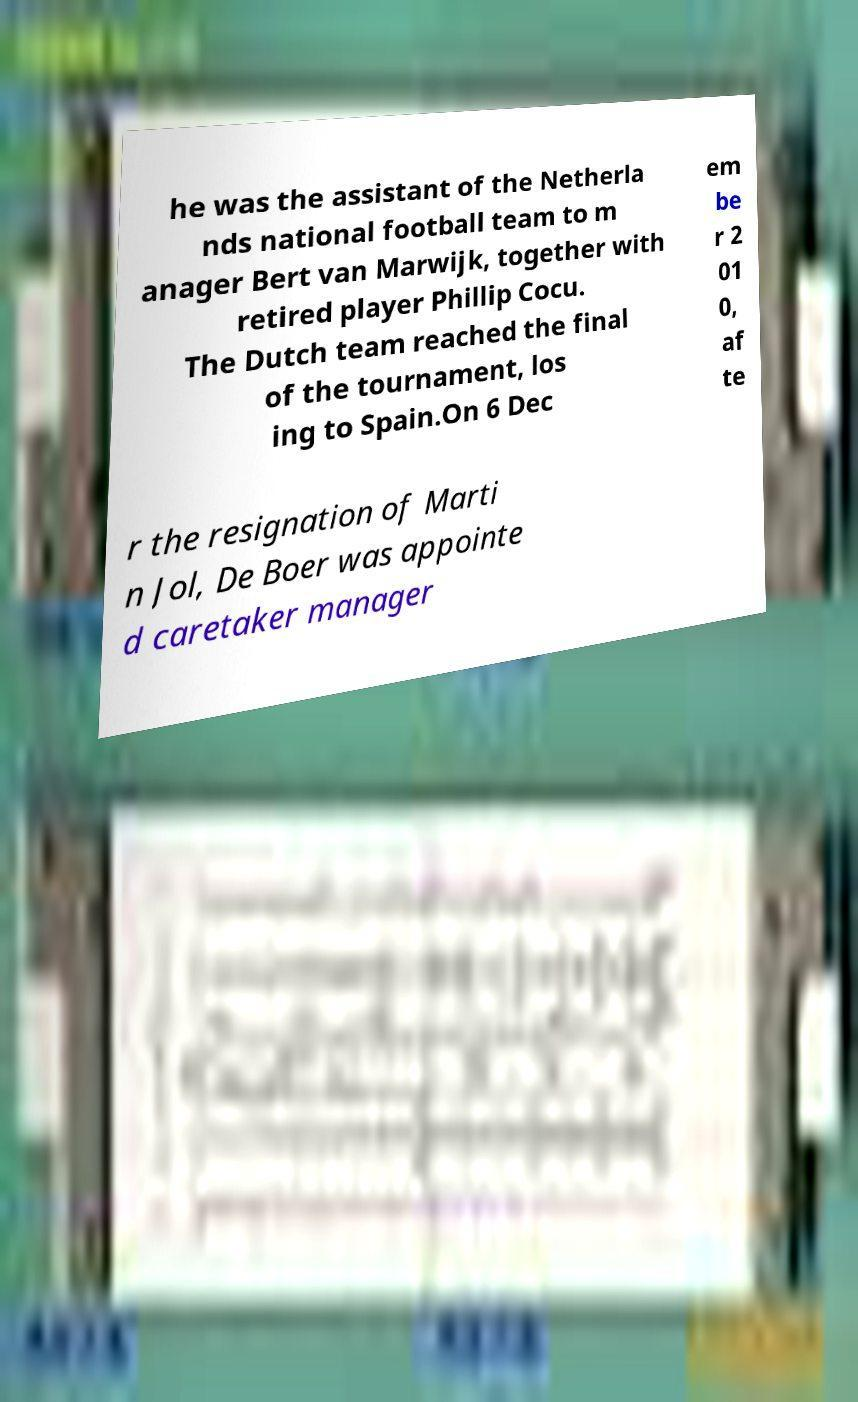Could you extract and type out the text from this image? he was the assistant of the Netherla nds national football team to m anager Bert van Marwijk, together with retired player Phillip Cocu. The Dutch team reached the final of the tournament, los ing to Spain.On 6 Dec em be r 2 01 0, af te r the resignation of Marti n Jol, De Boer was appointe d caretaker manager 